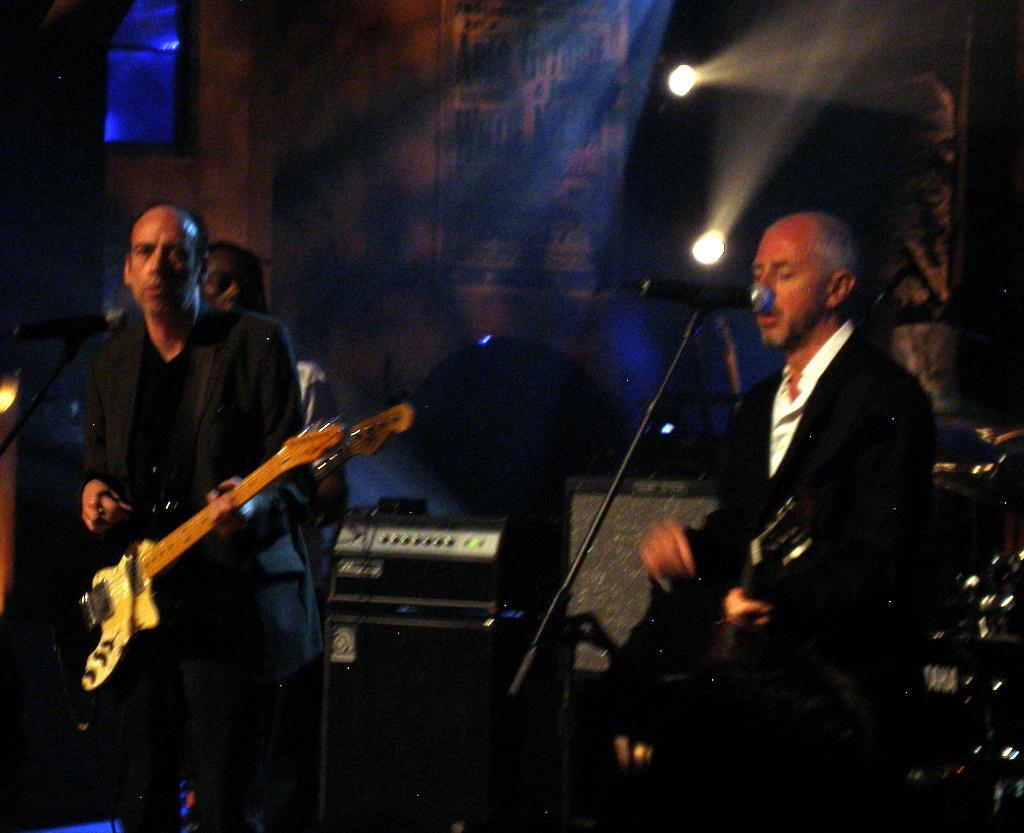In one or two sentences, can you explain what this image depicts? This picture is of inside. On the right there is a man wearing black color suit, standing, playing a musical instrument and singing. On the left there is another man standing and playing a guitar. There is a microphone attached to the stand and there are some musical instruments. In the background there is a curtain and the focusing lights and a person. 